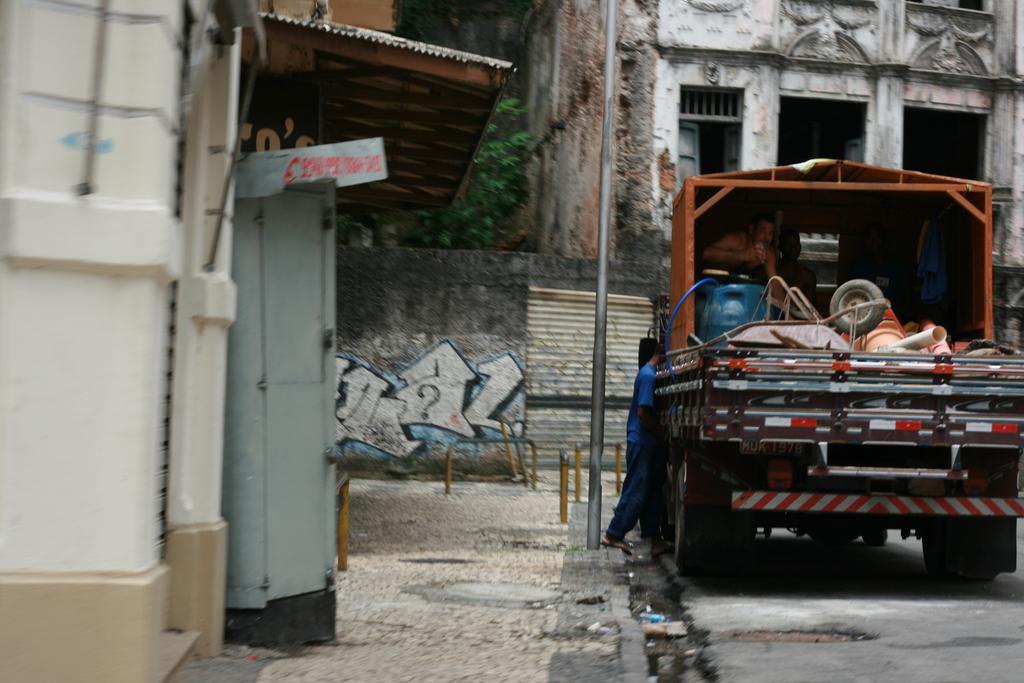Describe this image in one or two sentences. In this image, we can see a vehicle is on the road. Here we can see some objects, few people. Left side of the image, we can see a shed, door, board. Background there is a wall, few poles, tree, house, doors we can see. At the bottom, there is a footpath and road. 